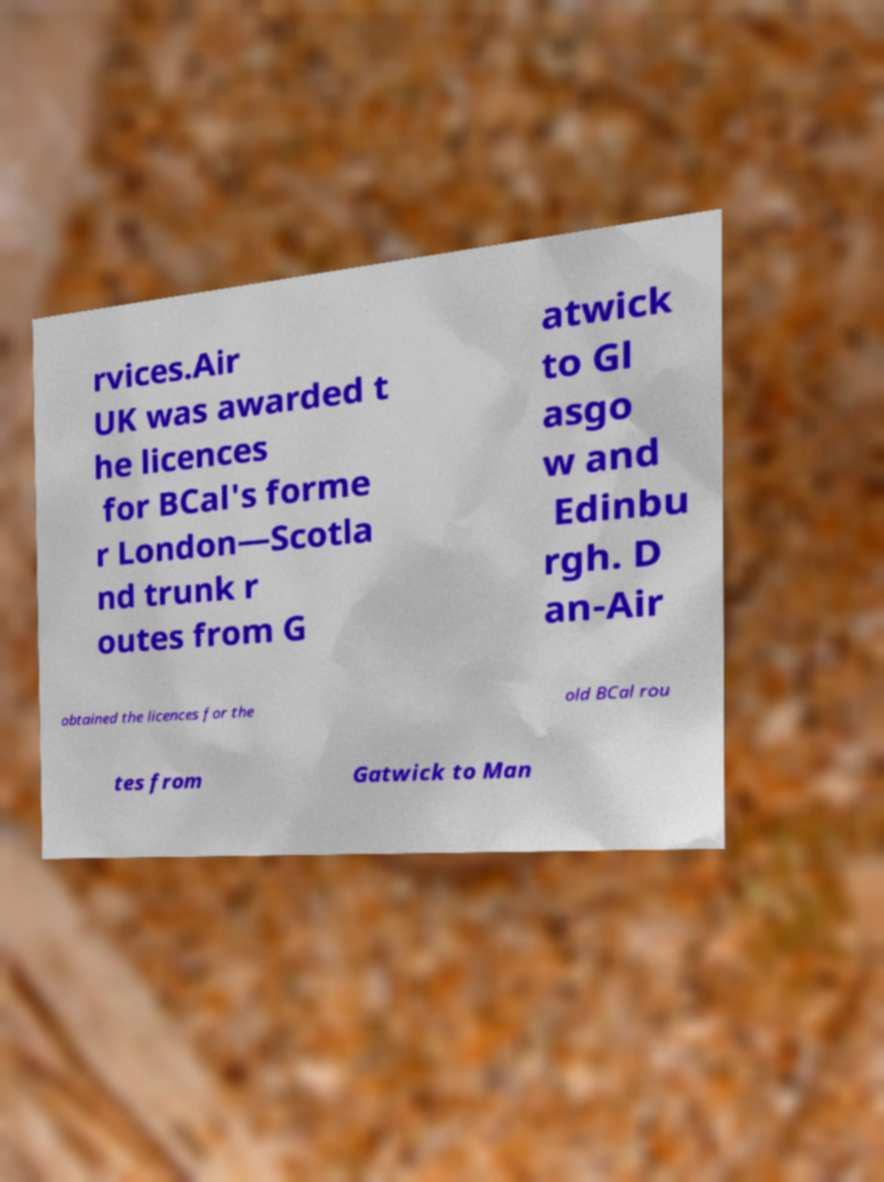Can you read and provide the text displayed in the image?This photo seems to have some interesting text. Can you extract and type it out for me? rvices.Air UK was awarded t he licences for BCal's forme r London—Scotla nd trunk r outes from G atwick to Gl asgo w and Edinbu rgh. D an-Air obtained the licences for the old BCal rou tes from Gatwick to Man 